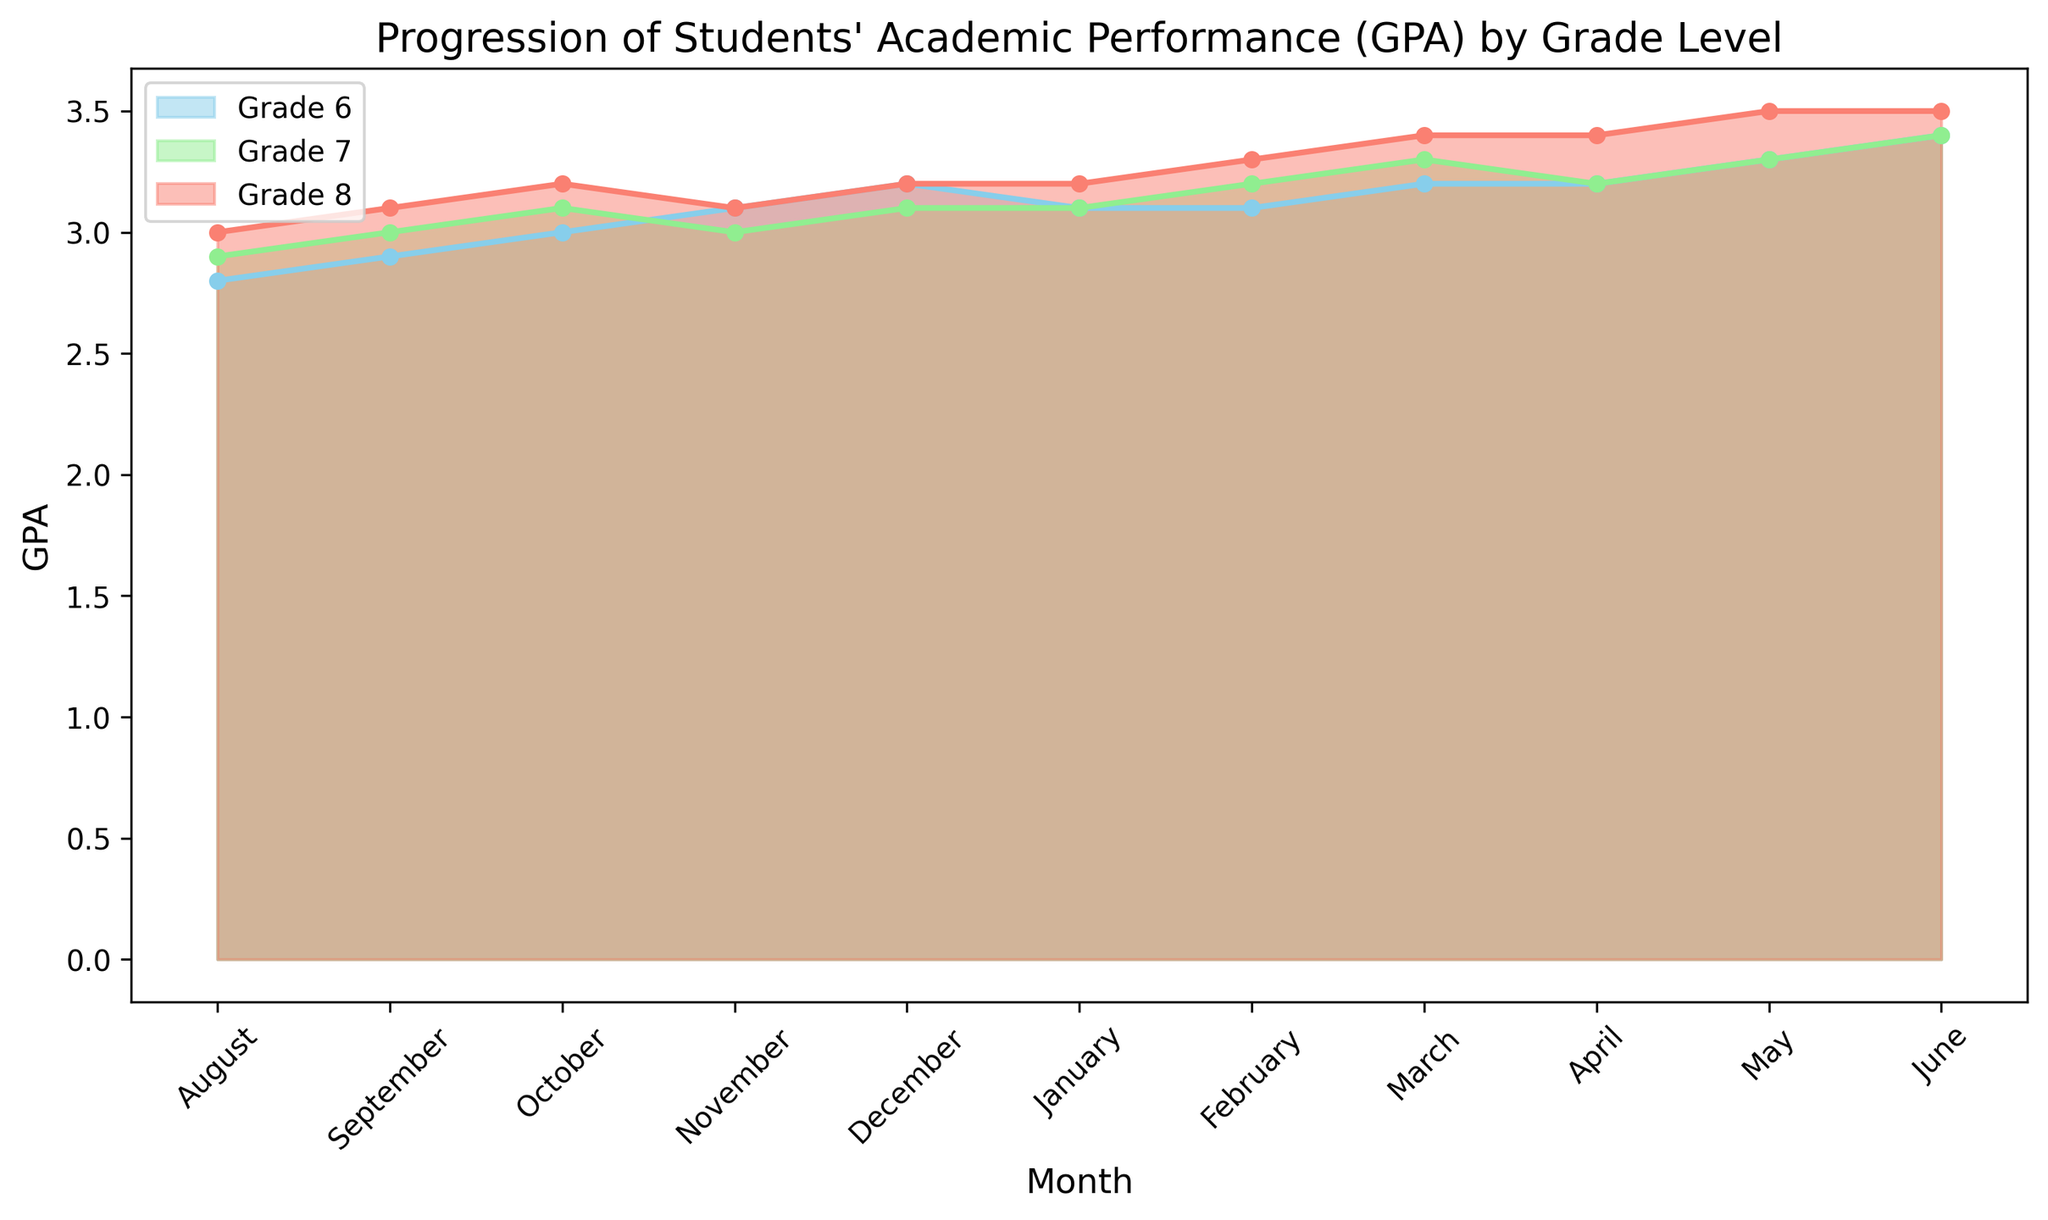Which grade level shows the most improvement in GPA from August to June? To find the grade level with the most improvement, we look at the difference in GPA from August to June for each grade. Grade 6 improves from 2.8 to 3.4, which is an improvement of 0.6. Grade 7 improves from 2.9 to 3.4, an improvement of 0.5. Grade 8 improves from 3.0 to 3.5, an improvement of 0.5. Therefore, Grade 6 shows the most improvement.
Answer: Grade 6 Which month shows the lowest GPA for Grade 8? We need to look at the GPA values for Grade 8 across all months. August has a GPA of 3.0, which is the lowest compared to the following months: September (3.1), October (3.2), November (3.1), December (3.2), January (3.2), February (3.3), March (3.4), April (3.4), May (3.5), and June (3.5).
Answer: August What is the average GPA in December for all grade levels? To find the average GPA in December, we add the GPA values for all grades in December and divide by the number of grades. The GPAs in December are: Grade 6 (3.2), Grade 7 (3.1), and Grade 8 (3.2). So, (3.2 + 3.1 + 3.2) / 3 = 9.5 / 3 = 3.17.
Answer: 3.17 Between which months does Grade 7 have the most significant increase in GPA? To find the most significant increase, we compare the changes in GPA between consecutive months for Grade 7. The most significant increase happens between February (3.2) and March (3.3), which is an increase of 0.1. This is the largest single-month increase for Grade 7.
Answer: February to March Which grade consistently shows a higher GPA across all months? We need to observe the GPA trends for all months across all grades. Grade 8 has the highest GPA values every month: August (3.0), September (3.1), October (3.2), November (3.1), December (3.2), January (3.2), February (3.3), March (3.4), April (3.4), May (3.5), and June (3.5).
Answer: Grade 8 In which months does Grade 6 have a GPA equal to 3.2? To find the months when Grade 6 has a GPA of 3.2, we look at the GPA values for each month. Grade 6 has a GPA of 3.2 in December, March, and April.
Answer: December, March, April How does the GPA of Grade 7 change from January to June? We look at the GPA values for Grade 7 from January (3.1) to June (3.4). From January to February it remains 3.1, then it increases to 3.2 in February, 3.3 in March, stays 3.2 in April, returns to 3.3 in May, and finally reaches 3.4 in June. We observe an overall trend of improvement.
Answer: Improvement What is the sum of GPAs for all grade levels in November? To find the sum of GPAs in November, we add the GPA values for all grades: Grade 6 (3.1), Grade 7 (3.0), and Grade 8 (3.1). The sum is 3.1 + 3.0 + 3.1 = 9.2.
Answer: 9.2 Comparing Grade 6 and Grade 8, which grade has a higher average GPA across all months? We need to calculate the average GPA for each grade across all months. For Grade 6: (2.8 + 2.9 + 3.0 + 3.1 + 3.2 + 3.1 + 3.1 + 3.2 + 3.2 + 3.3 + 3.4) / 11 = 34.3 / 11 ≈ 3.12. For Grade 8: (3.0 + 3.1 + 3.2 + 3.1 + 3.2 + 3.2 + 3.3 + 3.4 + 3.4 + 3.5 + 3.5) / 11 = 36.9 / 11 ≈ 3.35. Grade 8 has a higher average GPA.
Answer: Grade 8 